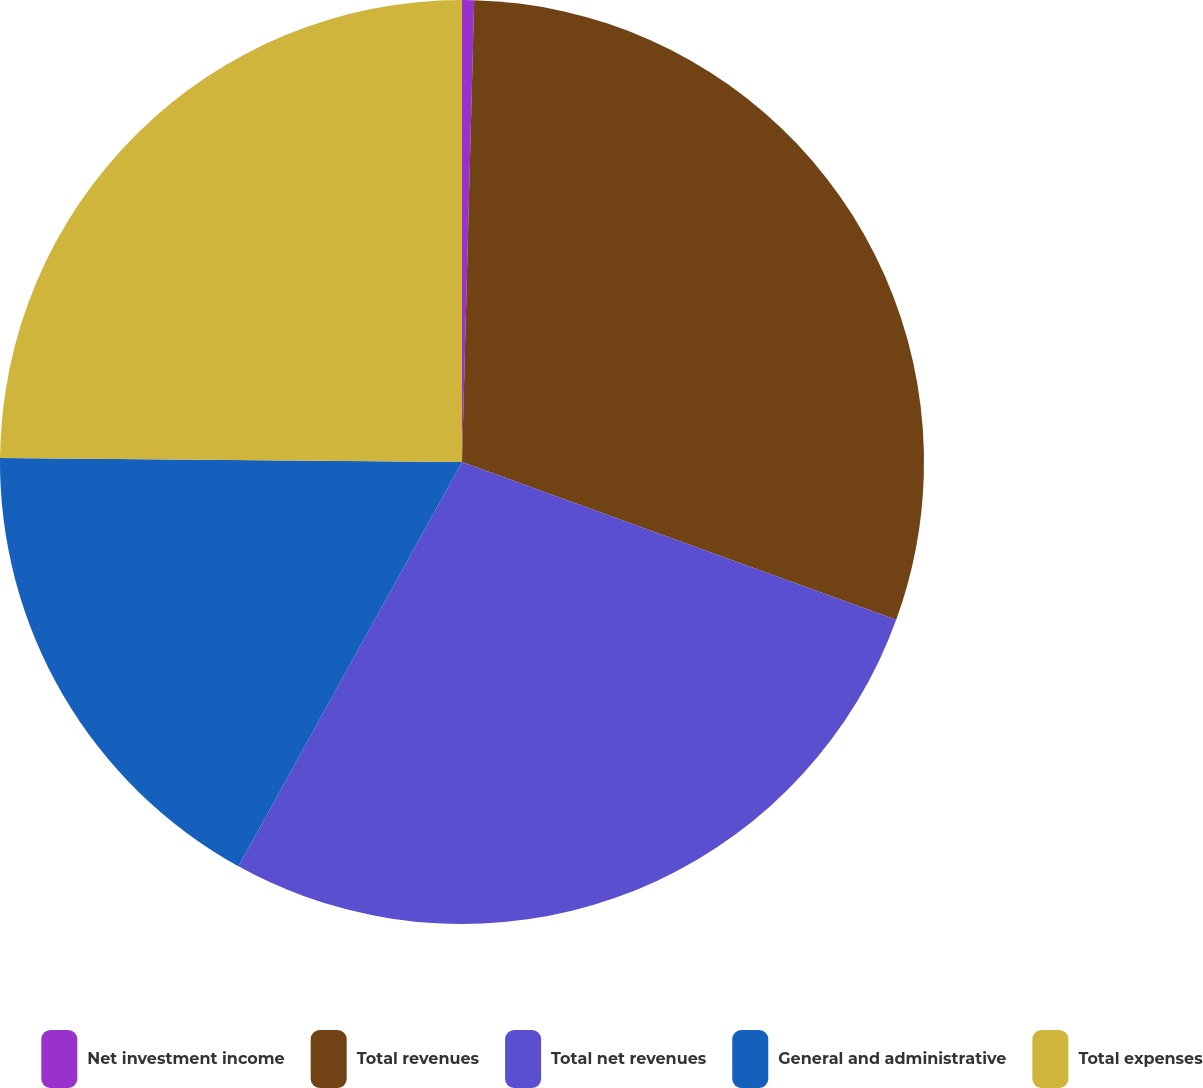<chart> <loc_0><loc_0><loc_500><loc_500><pie_chart><fcel>Net investment income<fcel>Total revenues<fcel>Total net revenues<fcel>General and administrative<fcel>Total expenses<nl><fcel>0.42%<fcel>30.13%<fcel>27.49%<fcel>17.1%<fcel>24.86%<nl></chart> 